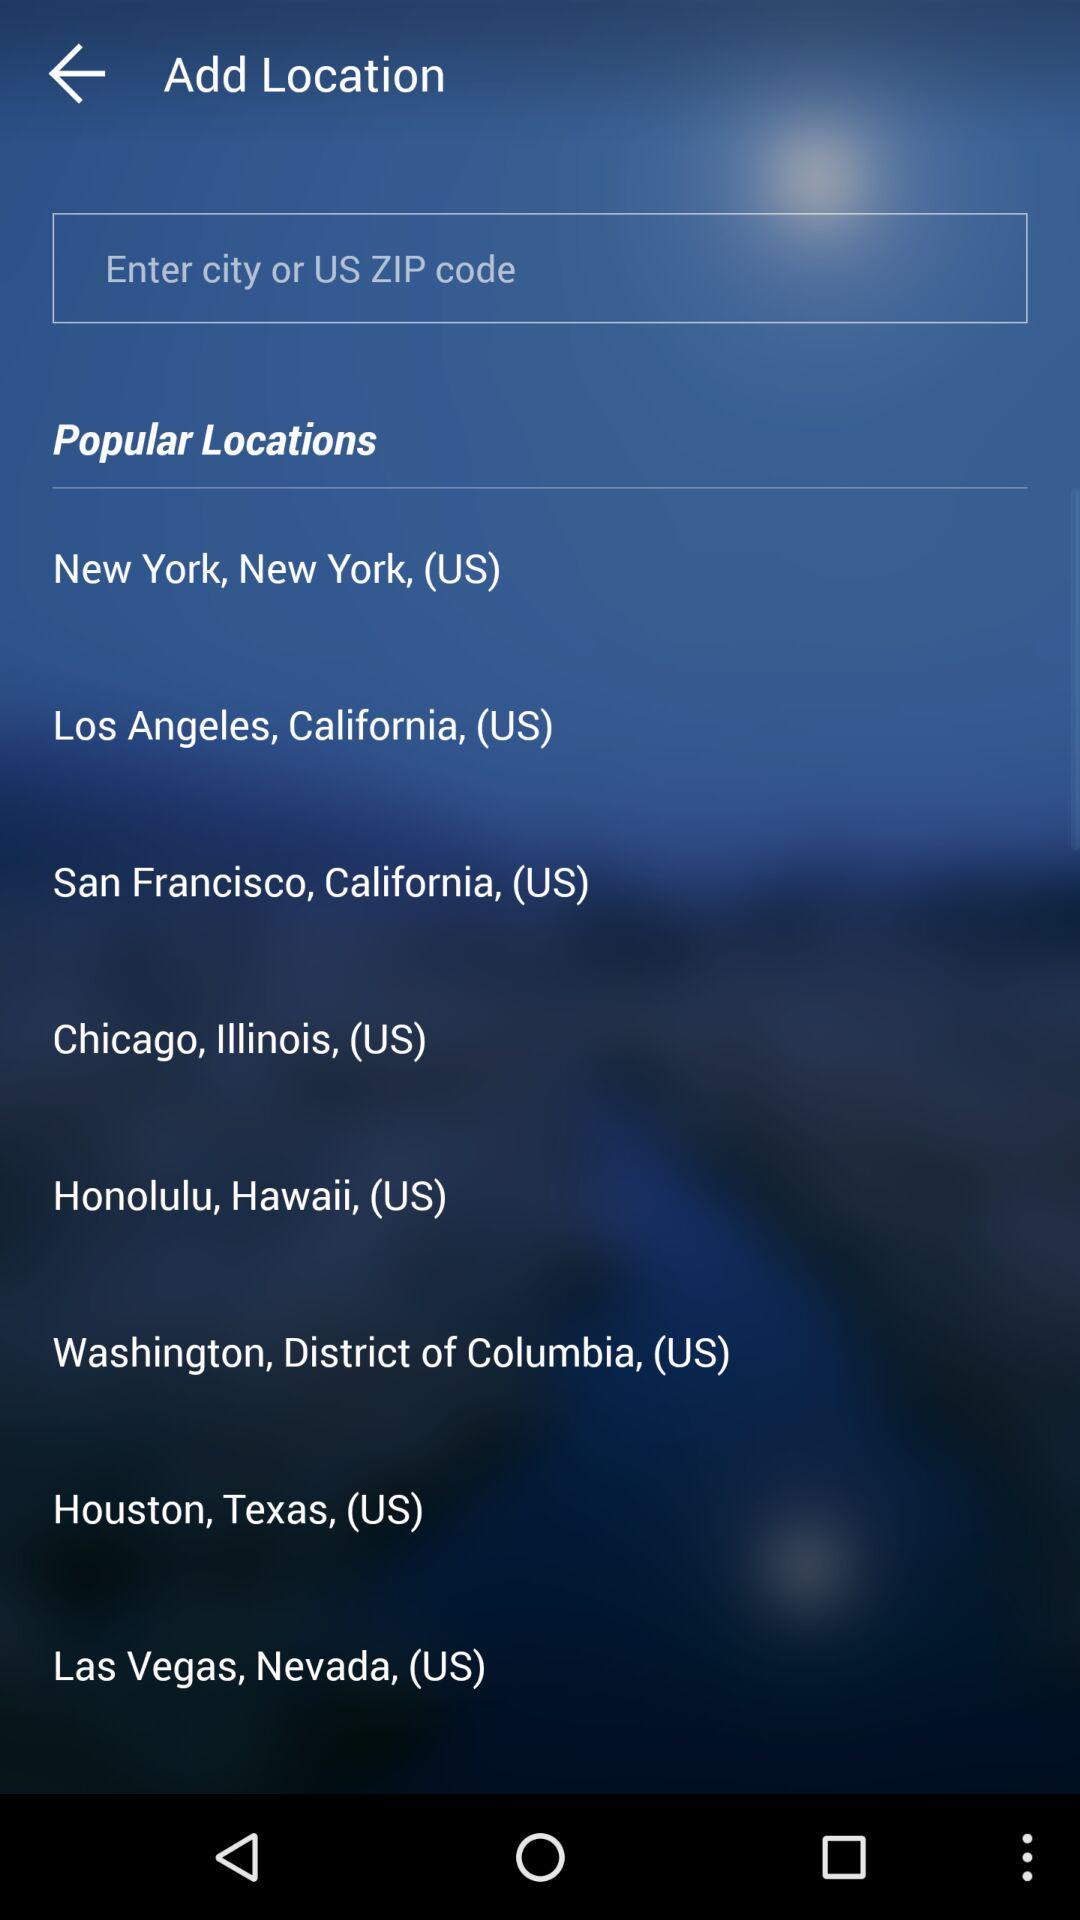What are the names of the different popular locations listed? The names of the different listed popular locations are New York in New York (US), Los Angeles in California (US), San Francisco in California (US), Chicago in Illinois (US), Honolulu in Hawaii (US), Washington in the District of Columbia (US), Houston in Texas (US) and Las Vegas in Nevada (US). 